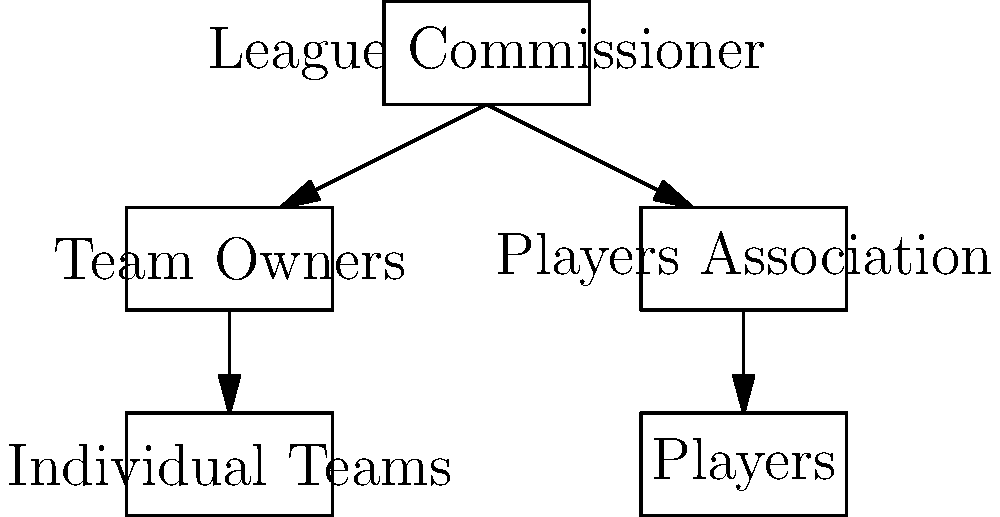Based on the organizational chart of a typical sports league, which entity serves as the primary intermediary between team owners and players, often negotiating collective bargaining agreements? To answer this question, let's analyze the organizational chart step-by-step:

1. At the top of the chart, we see the "League Commissioner," who oversees the entire league structure.

2. Directly below the Commissioner, we have two main entities: "Team Owners" and "Players Association."

3. The "Team Owners" branch leads to "Individual Teams," which represent the various franchises in the league.

4. The "Players Association" branch leads to "Players," representing the athletes who compete in the league.

5. The key relationship to focus on is between "Team Owners" and "Players Association."

6. In sports law, the Players Association typically acts as a union representing the collective interests of the players.

7. The Players Association negotiates with team owners (or their representatives) on behalf of the players to establish terms and conditions of employment, including salaries, benefits, and working conditions.

8. These negotiations often result in Collective Bargaining Agreements (CBAs), which are legally binding contracts between the league/team owners and the players.

9. The Players Association serves as a buffer between individual players and team owners, ensuring that players' rights are protected and that they have a unified voice in league matters.

Given this structure and the role of the Players Association in sports law, it is clear that the Players Association serves as the primary intermediary between team owners and players, negotiating collective bargaining agreements and representing player interests.
Answer: Players Association 